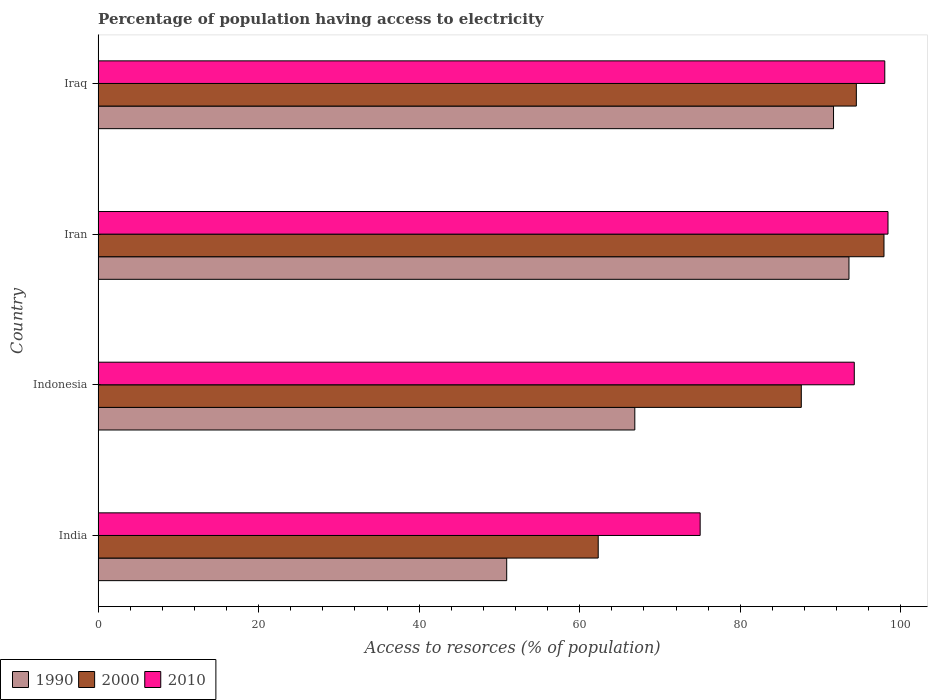How many different coloured bars are there?
Make the answer very short. 3. How many groups of bars are there?
Keep it short and to the point. 4. Are the number of bars on each tick of the Y-axis equal?
Your response must be concise. Yes. How many bars are there on the 4th tick from the top?
Keep it short and to the point. 3. What is the label of the 4th group of bars from the top?
Give a very brief answer. India. In how many cases, is the number of bars for a given country not equal to the number of legend labels?
Your answer should be compact. 0. What is the percentage of population having access to electricity in 2000 in India?
Offer a terse response. 62.3. Across all countries, what is the maximum percentage of population having access to electricity in 2000?
Ensure brevity in your answer.  97.9. Across all countries, what is the minimum percentage of population having access to electricity in 2000?
Offer a terse response. 62.3. In which country was the percentage of population having access to electricity in 2000 maximum?
Your answer should be very brief. Iran. In which country was the percentage of population having access to electricity in 1990 minimum?
Ensure brevity in your answer.  India. What is the total percentage of population having access to electricity in 1990 in the graph?
Your answer should be compact. 302.91. What is the difference between the percentage of population having access to electricity in 2000 in India and the percentage of population having access to electricity in 1990 in Iran?
Your response must be concise. -31.24. What is the average percentage of population having access to electricity in 2010 per country?
Keep it short and to the point. 91.4. What is the difference between the percentage of population having access to electricity in 2010 and percentage of population having access to electricity in 1990 in Iraq?
Provide a short and direct response. 6.38. In how many countries, is the percentage of population having access to electricity in 2010 greater than 48 %?
Keep it short and to the point. 4. What is the ratio of the percentage of population having access to electricity in 2000 in Indonesia to that in Iraq?
Make the answer very short. 0.93. What is the difference between the highest and the second highest percentage of population having access to electricity in 1990?
Keep it short and to the point. 1.92. What is the difference between the highest and the lowest percentage of population having access to electricity in 1990?
Your answer should be compact. 42.64. What does the 2nd bar from the top in Iraq represents?
Keep it short and to the point. 2000. What does the 1st bar from the bottom in Iran represents?
Give a very brief answer. 1990. Where does the legend appear in the graph?
Keep it short and to the point. Bottom left. How many legend labels are there?
Your answer should be compact. 3. What is the title of the graph?
Keep it short and to the point. Percentage of population having access to electricity. Does "2000" appear as one of the legend labels in the graph?
Offer a very short reply. Yes. What is the label or title of the X-axis?
Ensure brevity in your answer.  Access to resorces (% of population). What is the label or title of the Y-axis?
Provide a short and direct response. Country. What is the Access to resorces (% of population) of 1990 in India?
Provide a succinct answer. 50.9. What is the Access to resorces (% of population) of 2000 in India?
Make the answer very short. 62.3. What is the Access to resorces (% of population) in 1990 in Indonesia?
Make the answer very short. 66.86. What is the Access to resorces (% of population) of 2000 in Indonesia?
Offer a very short reply. 87.6. What is the Access to resorces (% of population) of 2010 in Indonesia?
Your response must be concise. 94.2. What is the Access to resorces (% of population) in 1990 in Iran?
Your response must be concise. 93.54. What is the Access to resorces (% of population) of 2000 in Iran?
Offer a very short reply. 97.9. What is the Access to resorces (% of population) in 2010 in Iran?
Give a very brief answer. 98.4. What is the Access to resorces (% of population) in 1990 in Iraq?
Provide a succinct answer. 91.62. What is the Access to resorces (% of population) in 2000 in Iraq?
Offer a very short reply. 94.46. What is the Access to resorces (% of population) in 2010 in Iraq?
Your answer should be compact. 98. Across all countries, what is the maximum Access to resorces (% of population) of 1990?
Your answer should be compact. 93.54. Across all countries, what is the maximum Access to resorces (% of population) of 2000?
Make the answer very short. 97.9. Across all countries, what is the maximum Access to resorces (% of population) in 2010?
Your response must be concise. 98.4. Across all countries, what is the minimum Access to resorces (% of population) of 1990?
Your response must be concise. 50.9. Across all countries, what is the minimum Access to resorces (% of population) of 2000?
Your answer should be compact. 62.3. Across all countries, what is the minimum Access to resorces (% of population) of 2010?
Offer a very short reply. 75. What is the total Access to resorces (% of population) in 1990 in the graph?
Give a very brief answer. 302.91. What is the total Access to resorces (% of population) in 2000 in the graph?
Make the answer very short. 342.26. What is the total Access to resorces (% of population) of 2010 in the graph?
Provide a short and direct response. 365.6. What is the difference between the Access to resorces (% of population) in 1990 in India and that in Indonesia?
Provide a succinct answer. -15.96. What is the difference between the Access to resorces (% of population) of 2000 in India and that in Indonesia?
Give a very brief answer. -25.3. What is the difference between the Access to resorces (% of population) in 2010 in India and that in Indonesia?
Offer a very short reply. -19.2. What is the difference between the Access to resorces (% of population) in 1990 in India and that in Iran?
Your answer should be very brief. -42.64. What is the difference between the Access to resorces (% of population) of 2000 in India and that in Iran?
Your answer should be compact. -35.6. What is the difference between the Access to resorces (% of population) of 2010 in India and that in Iran?
Keep it short and to the point. -23.4. What is the difference between the Access to resorces (% of population) in 1990 in India and that in Iraq?
Ensure brevity in your answer.  -40.72. What is the difference between the Access to resorces (% of population) of 2000 in India and that in Iraq?
Ensure brevity in your answer.  -32.16. What is the difference between the Access to resorces (% of population) of 2010 in India and that in Iraq?
Provide a succinct answer. -23. What is the difference between the Access to resorces (% of population) in 1990 in Indonesia and that in Iran?
Provide a succinct answer. -26.68. What is the difference between the Access to resorces (% of population) of 2000 in Indonesia and that in Iran?
Offer a very short reply. -10.3. What is the difference between the Access to resorces (% of population) in 1990 in Indonesia and that in Iraq?
Provide a short and direct response. -24.76. What is the difference between the Access to resorces (% of population) of 2000 in Indonesia and that in Iraq?
Offer a terse response. -6.86. What is the difference between the Access to resorces (% of population) of 1990 in Iran and that in Iraq?
Offer a very short reply. 1.92. What is the difference between the Access to resorces (% of population) of 2000 in Iran and that in Iraq?
Offer a very short reply. 3.44. What is the difference between the Access to resorces (% of population) of 1990 in India and the Access to resorces (% of population) of 2000 in Indonesia?
Offer a terse response. -36.7. What is the difference between the Access to resorces (% of population) of 1990 in India and the Access to resorces (% of population) of 2010 in Indonesia?
Provide a succinct answer. -43.3. What is the difference between the Access to resorces (% of population) of 2000 in India and the Access to resorces (% of population) of 2010 in Indonesia?
Make the answer very short. -31.9. What is the difference between the Access to resorces (% of population) of 1990 in India and the Access to resorces (% of population) of 2000 in Iran?
Offer a very short reply. -47. What is the difference between the Access to resorces (% of population) of 1990 in India and the Access to resorces (% of population) of 2010 in Iran?
Provide a succinct answer. -47.5. What is the difference between the Access to resorces (% of population) of 2000 in India and the Access to resorces (% of population) of 2010 in Iran?
Offer a very short reply. -36.1. What is the difference between the Access to resorces (% of population) in 1990 in India and the Access to resorces (% of population) in 2000 in Iraq?
Offer a very short reply. -43.56. What is the difference between the Access to resorces (% of population) of 1990 in India and the Access to resorces (% of population) of 2010 in Iraq?
Give a very brief answer. -47.1. What is the difference between the Access to resorces (% of population) of 2000 in India and the Access to resorces (% of population) of 2010 in Iraq?
Your answer should be very brief. -35.7. What is the difference between the Access to resorces (% of population) of 1990 in Indonesia and the Access to resorces (% of population) of 2000 in Iran?
Offer a very short reply. -31.04. What is the difference between the Access to resorces (% of population) in 1990 in Indonesia and the Access to resorces (% of population) in 2010 in Iran?
Offer a terse response. -31.54. What is the difference between the Access to resorces (% of population) of 2000 in Indonesia and the Access to resorces (% of population) of 2010 in Iran?
Make the answer very short. -10.8. What is the difference between the Access to resorces (% of population) of 1990 in Indonesia and the Access to resorces (% of population) of 2000 in Iraq?
Offer a very short reply. -27.6. What is the difference between the Access to resorces (% of population) of 1990 in Indonesia and the Access to resorces (% of population) of 2010 in Iraq?
Your answer should be compact. -31.14. What is the difference between the Access to resorces (% of population) of 2000 in Indonesia and the Access to resorces (% of population) of 2010 in Iraq?
Offer a terse response. -10.4. What is the difference between the Access to resorces (% of population) of 1990 in Iran and the Access to resorces (% of population) of 2000 in Iraq?
Your answer should be compact. -0.92. What is the difference between the Access to resorces (% of population) of 1990 in Iran and the Access to resorces (% of population) of 2010 in Iraq?
Provide a succinct answer. -4.46. What is the difference between the Access to resorces (% of population) of 2000 in Iran and the Access to resorces (% of population) of 2010 in Iraq?
Your answer should be compact. -0.1. What is the average Access to resorces (% of population) of 1990 per country?
Provide a succinct answer. 75.73. What is the average Access to resorces (% of population) in 2000 per country?
Give a very brief answer. 85.56. What is the average Access to resorces (% of population) of 2010 per country?
Your answer should be very brief. 91.4. What is the difference between the Access to resorces (% of population) in 1990 and Access to resorces (% of population) in 2000 in India?
Offer a terse response. -11.4. What is the difference between the Access to resorces (% of population) in 1990 and Access to resorces (% of population) in 2010 in India?
Offer a terse response. -24.1. What is the difference between the Access to resorces (% of population) of 1990 and Access to resorces (% of population) of 2000 in Indonesia?
Offer a terse response. -20.74. What is the difference between the Access to resorces (% of population) of 1990 and Access to resorces (% of population) of 2010 in Indonesia?
Give a very brief answer. -27.34. What is the difference between the Access to resorces (% of population) in 2000 and Access to resorces (% of population) in 2010 in Indonesia?
Your answer should be compact. -6.6. What is the difference between the Access to resorces (% of population) of 1990 and Access to resorces (% of population) of 2000 in Iran?
Make the answer very short. -4.36. What is the difference between the Access to resorces (% of population) of 1990 and Access to resorces (% of population) of 2010 in Iran?
Offer a very short reply. -4.86. What is the difference between the Access to resorces (% of population) in 2000 and Access to resorces (% of population) in 2010 in Iran?
Your answer should be very brief. -0.5. What is the difference between the Access to resorces (% of population) in 1990 and Access to resorces (% of population) in 2000 in Iraq?
Your answer should be very brief. -2.84. What is the difference between the Access to resorces (% of population) of 1990 and Access to resorces (% of population) of 2010 in Iraq?
Provide a succinct answer. -6.38. What is the difference between the Access to resorces (% of population) in 2000 and Access to resorces (% of population) in 2010 in Iraq?
Offer a terse response. -3.54. What is the ratio of the Access to resorces (% of population) of 1990 in India to that in Indonesia?
Keep it short and to the point. 0.76. What is the ratio of the Access to resorces (% of population) in 2000 in India to that in Indonesia?
Provide a short and direct response. 0.71. What is the ratio of the Access to resorces (% of population) of 2010 in India to that in Indonesia?
Your answer should be compact. 0.8. What is the ratio of the Access to resorces (% of population) of 1990 in India to that in Iran?
Provide a succinct answer. 0.54. What is the ratio of the Access to resorces (% of population) of 2000 in India to that in Iran?
Provide a short and direct response. 0.64. What is the ratio of the Access to resorces (% of population) in 2010 in India to that in Iran?
Offer a terse response. 0.76. What is the ratio of the Access to resorces (% of population) of 1990 in India to that in Iraq?
Ensure brevity in your answer.  0.56. What is the ratio of the Access to resorces (% of population) of 2000 in India to that in Iraq?
Offer a very short reply. 0.66. What is the ratio of the Access to resorces (% of population) in 2010 in India to that in Iraq?
Your response must be concise. 0.77. What is the ratio of the Access to resorces (% of population) of 1990 in Indonesia to that in Iran?
Your response must be concise. 0.71. What is the ratio of the Access to resorces (% of population) of 2000 in Indonesia to that in Iran?
Make the answer very short. 0.89. What is the ratio of the Access to resorces (% of population) in 2010 in Indonesia to that in Iran?
Provide a short and direct response. 0.96. What is the ratio of the Access to resorces (% of population) in 1990 in Indonesia to that in Iraq?
Ensure brevity in your answer.  0.73. What is the ratio of the Access to resorces (% of population) in 2000 in Indonesia to that in Iraq?
Provide a succinct answer. 0.93. What is the ratio of the Access to resorces (% of population) of 2010 in Indonesia to that in Iraq?
Your answer should be very brief. 0.96. What is the ratio of the Access to resorces (% of population) of 2000 in Iran to that in Iraq?
Your response must be concise. 1.04. What is the difference between the highest and the second highest Access to resorces (% of population) in 1990?
Provide a succinct answer. 1.92. What is the difference between the highest and the second highest Access to resorces (% of population) in 2000?
Provide a short and direct response. 3.44. What is the difference between the highest and the second highest Access to resorces (% of population) in 2010?
Provide a succinct answer. 0.4. What is the difference between the highest and the lowest Access to resorces (% of population) of 1990?
Ensure brevity in your answer.  42.64. What is the difference between the highest and the lowest Access to resorces (% of population) in 2000?
Your answer should be compact. 35.6. What is the difference between the highest and the lowest Access to resorces (% of population) of 2010?
Provide a succinct answer. 23.4. 